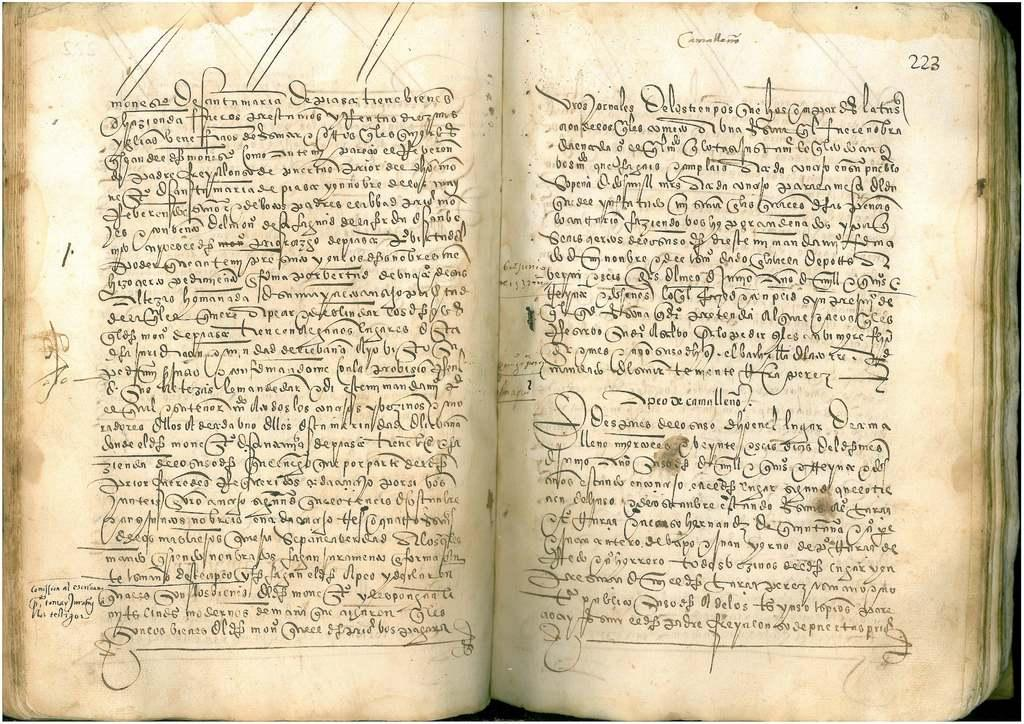<image>
Offer a succinct explanation of the picture presented. A very old book that is opened to page 222 and 223. 